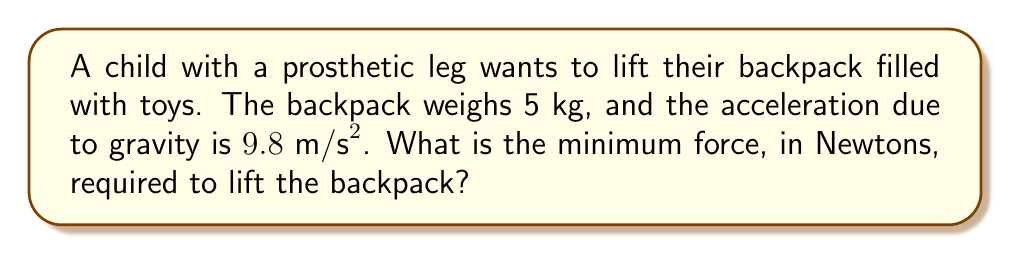Teach me how to tackle this problem. To solve this problem, we'll use Newton's Second Law of Motion, which states that the force (F) is equal to the mass (m) multiplied by the acceleration (a).

Step 1: Identify the given information
- Mass of the backpack (m) = 5 kg
- Acceleration due to gravity (g) = $9.8 \text{ m/s}^2$

Step 2: Determine the acceleration needed
To lift the backpack, we need to overcome gravity. The minimum force required will be when the backpack is just about to lift off, meaning its acceleration relative to the ground is zero. Therefore, we only need to counteract the force of gravity.

Step 3: Apply Newton's Second Law
The force of gravity pulling down on the backpack is:

$$F_g = m \cdot g$$

Where:
$F_g$ is the force of gravity
$m$ is the mass of the backpack
$g$ is the acceleration due to gravity

Step 4: Calculate the force
$$F_g = 5 \text{ kg} \cdot 9.8 \text{ m/s}^2 = 49 \text{ N}$$

The minimum force required to lift the backpack must be equal and opposite to the force of gravity.
Answer: 49 N 